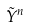Convert formula to latex. <formula><loc_0><loc_0><loc_500><loc_500>\tilde { Y } ^ { n }</formula> 